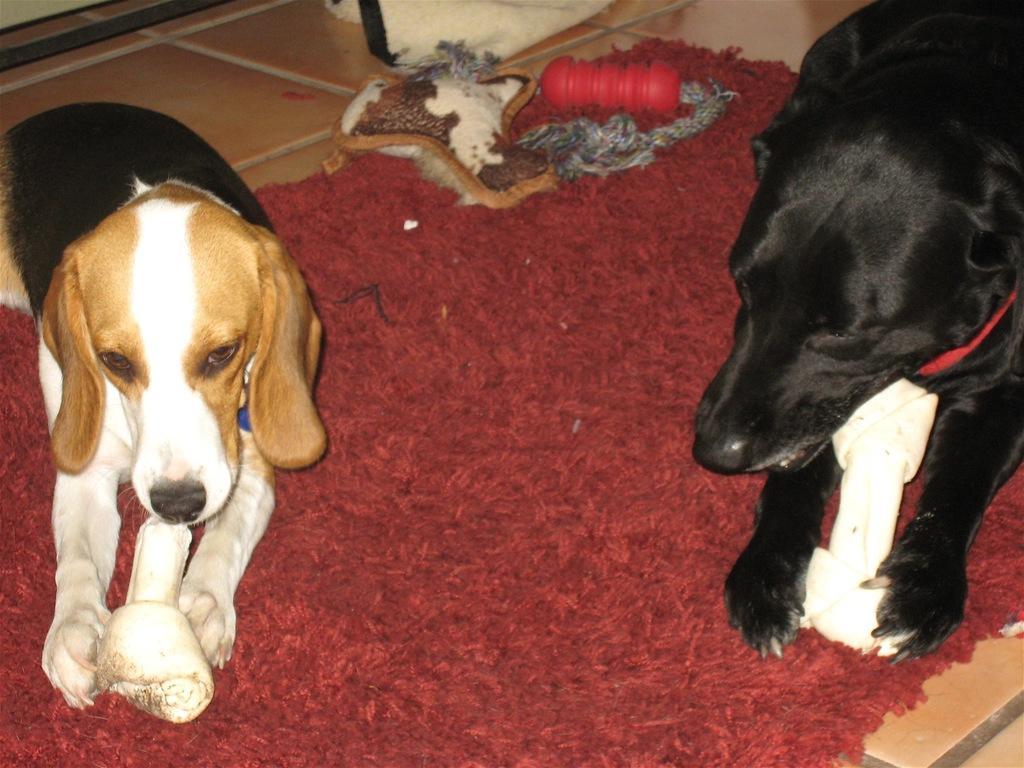How would you summarize this image in a sentence or two? In this image there are two dogs placing bones in their mouth and sitting on the mat, there are few objects on the mat, which is on the floor. 